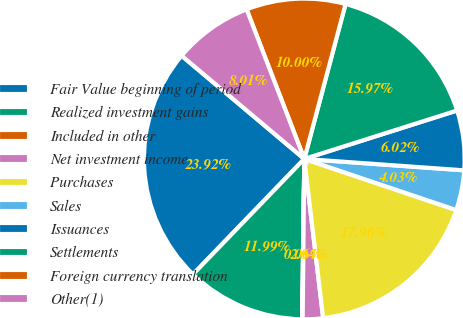Convert chart to OTSL. <chart><loc_0><loc_0><loc_500><loc_500><pie_chart><fcel>Fair Value beginning of period<fcel>Realized investment gains<fcel>Included in other<fcel>Net investment income<fcel>Purchases<fcel>Sales<fcel>Issuances<fcel>Settlements<fcel>Foreign currency translation<fcel>Other(1)<nl><fcel>23.92%<fcel>11.99%<fcel>0.06%<fcel>2.04%<fcel>17.96%<fcel>4.03%<fcel>6.02%<fcel>15.97%<fcel>10.0%<fcel>8.01%<nl></chart> 